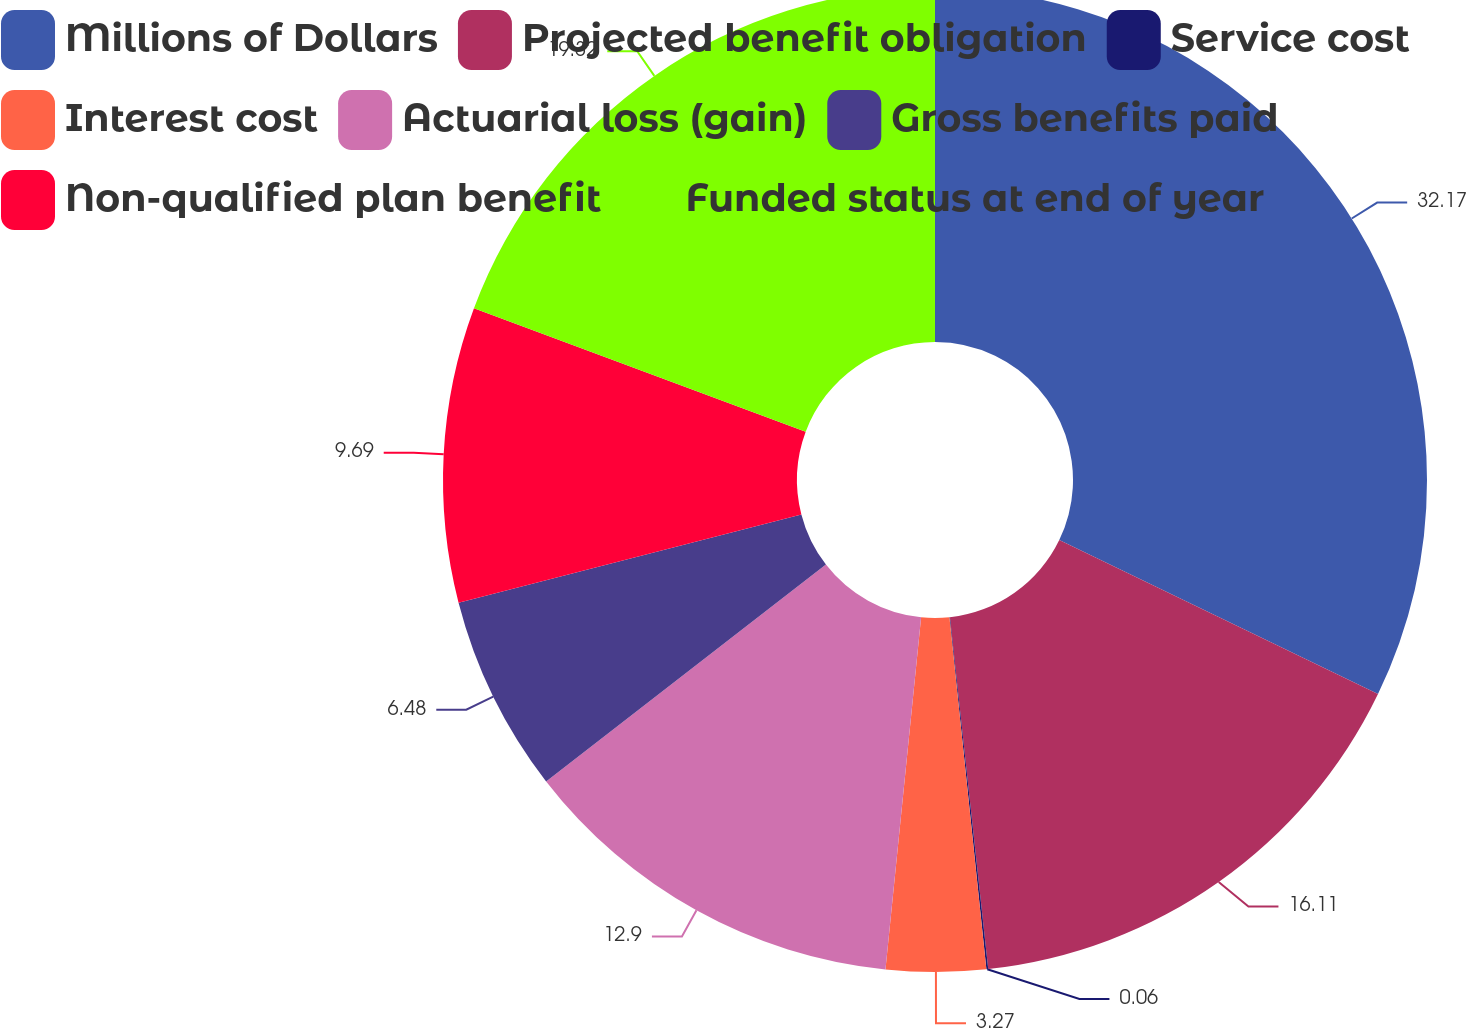Convert chart. <chart><loc_0><loc_0><loc_500><loc_500><pie_chart><fcel>Millions of Dollars<fcel>Projected benefit obligation<fcel>Service cost<fcel>Interest cost<fcel>Actuarial loss (gain)<fcel>Gross benefits paid<fcel>Non-qualified plan benefit<fcel>Funded status at end of year<nl><fcel>32.16%<fcel>16.11%<fcel>0.06%<fcel>3.27%<fcel>12.9%<fcel>6.48%<fcel>9.69%<fcel>19.32%<nl></chart> 